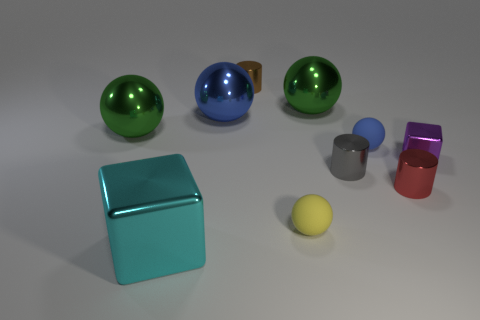How many blue objects are matte balls or large things?
Your answer should be very brief. 2. What number of metal things are in front of the blue rubber ball and behind the cyan object?
Ensure brevity in your answer.  3. What is the material of the small sphere that is behind the block that is on the right side of the matte sphere that is right of the tiny yellow rubber object?
Your answer should be very brief. Rubber. What number of green balls are the same material as the small blue sphere?
Your answer should be compact. 0. There is a yellow matte object that is the same size as the brown metallic object; what shape is it?
Your answer should be compact. Sphere. There is a tiny red cylinder; are there any small yellow matte spheres behind it?
Ensure brevity in your answer.  No. Is there a yellow rubber thing of the same shape as the blue rubber object?
Offer a very short reply. Yes. Does the metallic object in front of the tiny red shiny cylinder have the same shape as the big object that is on the right side of the big blue shiny thing?
Provide a succinct answer. No. Are there any yellow spheres that have the same size as the gray thing?
Keep it short and to the point. Yes. Is the number of tiny things in front of the tiny gray metal thing the same as the number of big objects that are on the right side of the big cyan cube?
Ensure brevity in your answer.  Yes. 